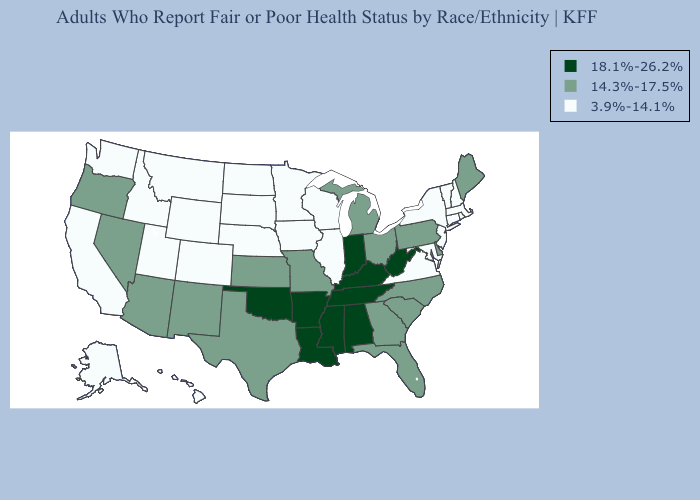Does the map have missing data?
Give a very brief answer. No. Does Mississippi have a higher value than Kentucky?
Quick response, please. No. What is the lowest value in the MidWest?
Quick response, please. 3.9%-14.1%. What is the lowest value in the South?
Keep it brief. 3.9%-14.1%. What is the value of Missouri?
Concise answer only. 14.3%-17.5%. Name the states that have a value in the range 18.1%-26.2%?
Give a very brief answer. Alabama, Arkansas, Indiana, Kentucky, Louisiana, Mississippi, Oklahoma, Tennessee, West Virginia. What is the value of Nebraska?
Short answer required. 3.9%-14.1%. Is the legend a continuous bar?
Quick response, please. No. Which states have the lowest value in the South?
Answer briefly. Maryland, Virginia. How many symbols are there in the legend?
Answer briefly. 3. What is the value of Louisiana?
Answer briefly. 18.1%-26.2%. Does Hawaii have the same value as Texas?
Be succinct. No. Does Oregon have the lowest value in the West?
Give a very brief answer. No. What is the highest value in the USA?
Short answer required. 18.1%-26.2%. Name the states that have a value in the range 18.1%-26.2%?
Quick response, please. Alabama, Arkansas, Indiana, Kentucky, Louisiana, Mississippi, Oklahoma, Tennessee, West Virginia. 